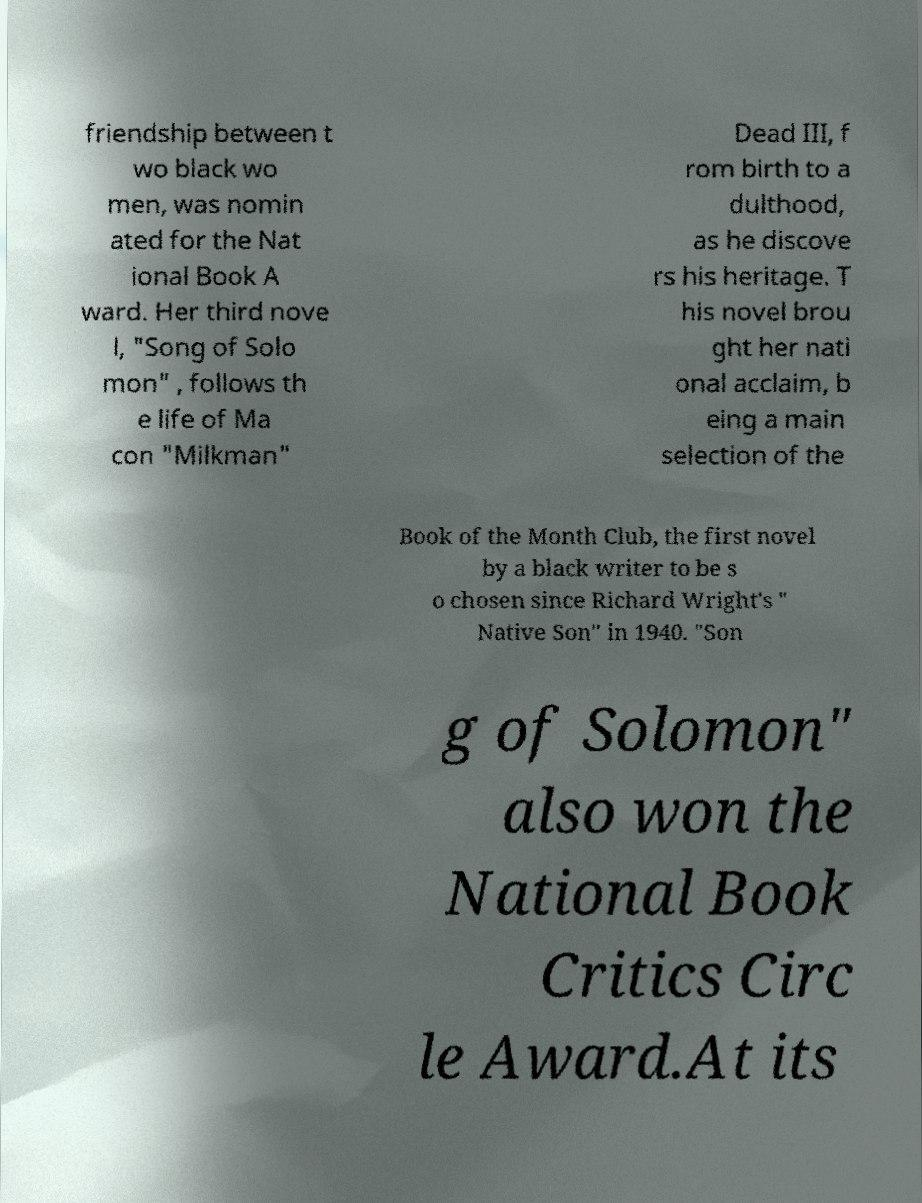What messages or text are displayed in this image? I need them in a readable, typed format. friendship between t wo black wo men, was nomin ated for the Nat ional Book A ward. Her third nove l, "Song of Solo mon" , follows th e life of Ma con "Milkman" Dead III, f rom birth to a dulthood, as he discove rs his heritage. T his novel brou ght her nati onal acclaim, b eing a main selection of the Book of the Month Club, the first novel by a black writer to be s o chosen since Richard Wright's " Native Son" in 1940. "Son g of Solomon" also won the National Book Critics Circ le Award.At its 